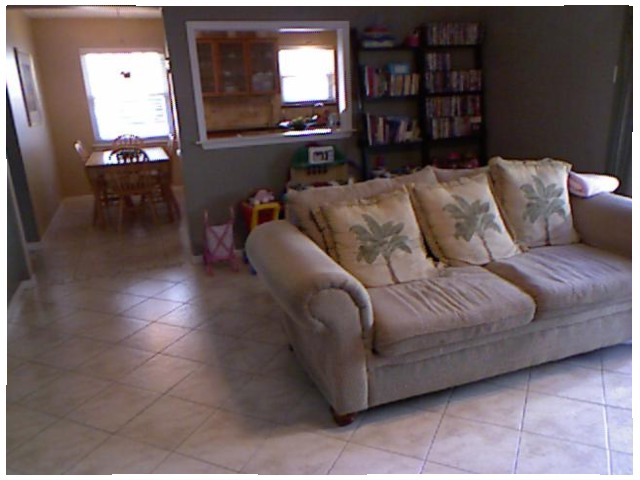<image>
Is there a sofa in front of the book self? Yes. The sofa is positioned in front of the book self, appearing closer to the camera viewpoint. Where is the pillow in relation to the seat bed? Is it on the seat bed? Yes. Looking at the image, I can see the pillow is positioned on top of the seat bed, with the seat bed providing support. Where is the shelf in relation to the toy? Is it on the toy? No. The shelf is not positioned on the toy. They may be near each other, but the shelf is not supported by or resting on top of the toy. 